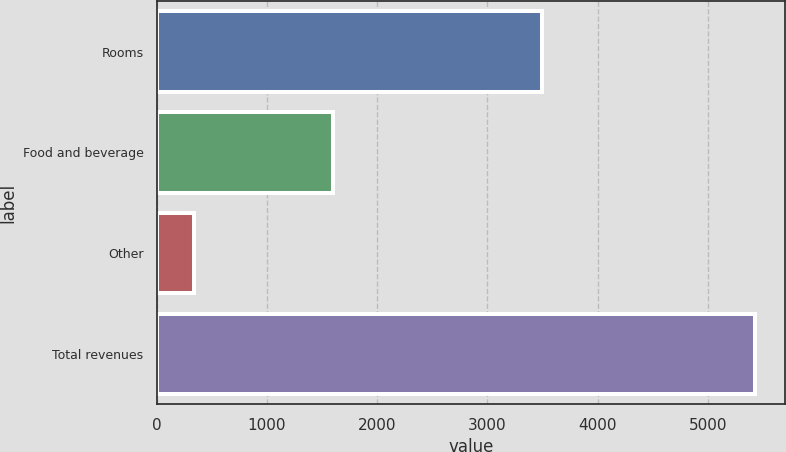<chart> <loc_0><loc_0><loc_500><loc_500><bar_chart><fcel>Rooms<fcel>Food and beverage<fcel>Other<fcel>Total revenues<nl><fcel>3492<fcel>1599<fcel>339<fcel>5430<nl></chart> 